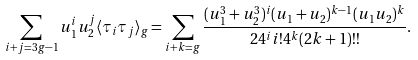<formula> <loc_0><loc_0><loc_500><loc_500>\sum _ { i + j = 3 g - 1 } u _ { 1 } ^ { i } u _ { 2 } ^ { j } \langle \tau _ { i } \tau _ { j } \rangle _ { g } = \sum _ { i + k = g } \frac { ( u _ { 1 } ^ { 3 } + u _ { 2 } ^ { 3 } ) ^ { i } ( u _ { 1 } + u _ { 2 } ) ^ { k - 1 } ( u _ { 1 } u _ { 2 } ) ^ { k } } { 2 4 ^ { i } i ! 4 ^ { k } ( 2 k + 1 ) ! ! } .</formula> 